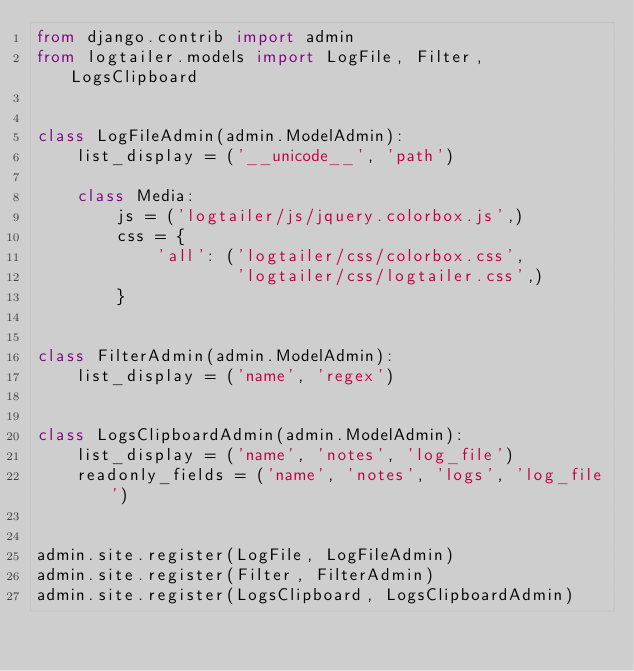Convert code to text. <code><loc_0><loc_0><loc_500><loc_500><_Python_>from django.contrib import admin
from logtailer.models import LogFile, Filter, LogsClipboard


class LogFileAdmin(admin.ModelAdmin):
    list_display = ('__unicode__', 'path')
    
    class Media:
        js = ('logtailer/js/jquery.colorbox.js',)
        css = {
            'all': ('logtailer/css/colorbox.css',
                    'logtailer/css/logtailer.css',)
        }


class FilterAdmin(admin.ModelAdmin):
    list_display = ('name', 'regex')   


class LogsClipboardAdmin(admin.ModelAdmin):
    list_display = ('name', 'notes', 'log_file')
    readonly_fields = ('name', 'notes', 'logs', 'log_file')


admin.site.register(LogFile, LogFileAdmin)
admin.site.register(Filter, FilterAdmin)
admin.site.register(LogsClipboard, LogsClipboardAdmin)</code> 